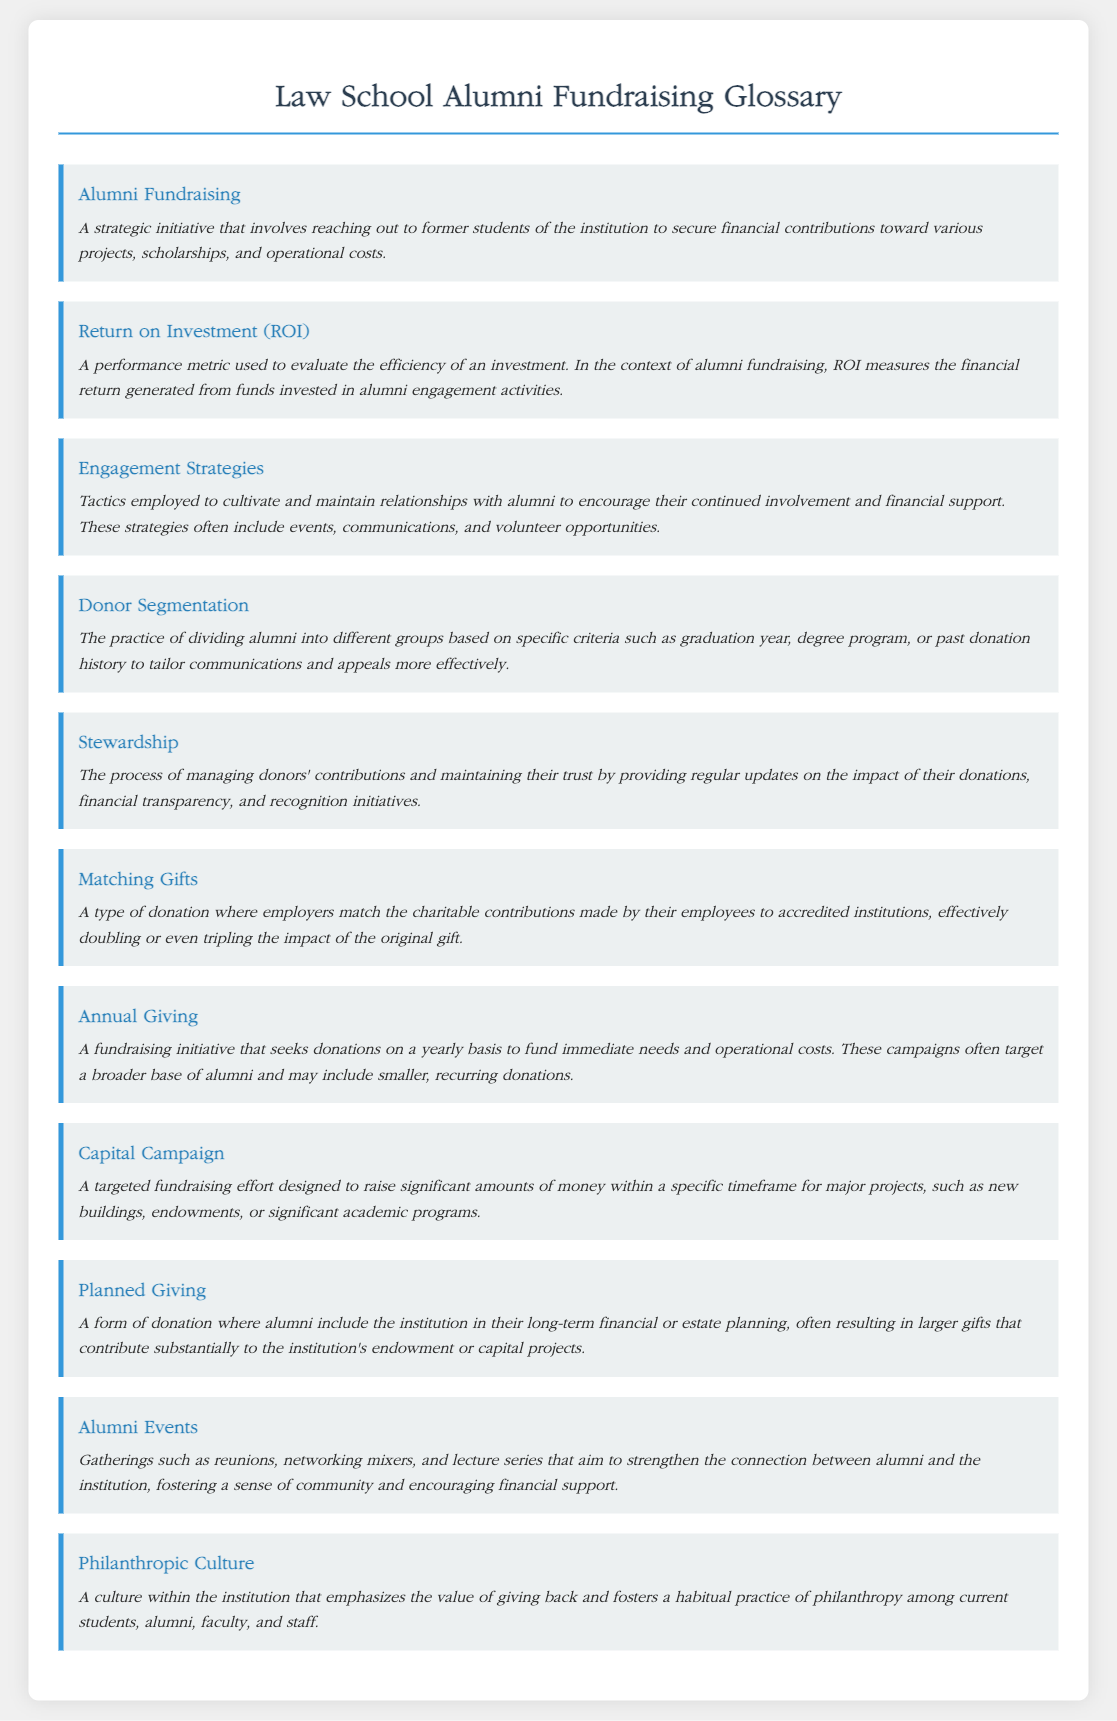what is the definition of Alumni Fundraising? The definition of Alumni Fundraising is provided in the glossary, describing it as a strategic initiative that involves reaching out to former students for financial contributions.
Answer: A strategic initiative that involves reaching out to former students of the institution to secure financial contributions toward various projects, scholarships, and operational costs what does ROI stand for? ROI is defined in the glossary as a performance metric used to evaluate the efficiency of an investment in alumni fundraising.
Answer: Return on Investment what is an example of an Engagement Strategy? The document outlines various tactics for maintaining relationships with alumni, which can be considered Engagement Strategies.
Answer: Events, communications, and volunteer opportunities which term describes the management of donor contributions? The glossary includes a term that describes managing donor contributions and maintaining their trust through financial transparency.
Answer: Stewardship what is the purpose of Donor Segmentation? The purpose of Donor Segmentation is given in the document as tailoring communications and appeals by dividing alumni into groups.
Answer: To tailor communications and appeals more effectively how often is Annual Giving sought? The glossary defines Annual Giving as a fundraising initiative that seeks donations on a yearly basis.
Answer: Yearly what type of campaign targets significant fundraising within a specific timeframe? The document specifies a type of campaign aimed at raising substantial money for major projects within a set period.
Answer: Capital Campaign what concept promotes philanthropy among students and alumni? The glossary describes a culture that emphasizes the value of giving back and fosters habitual philanthropy.
Answer: Philanthropic Culture what is the primary focus of Planned Giving? Planned Giving is explained in the glossary as including the institution in long-term financial or estate planning.
Answer: Long-term financial or estate planning 